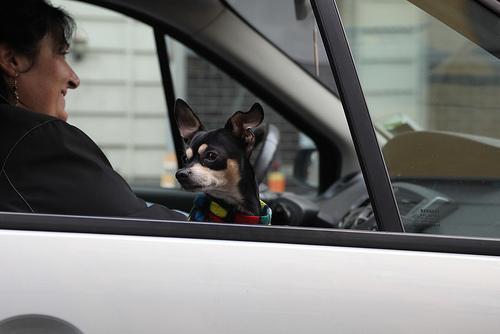How many dogs are there?
Give a very brief answer. 1. 